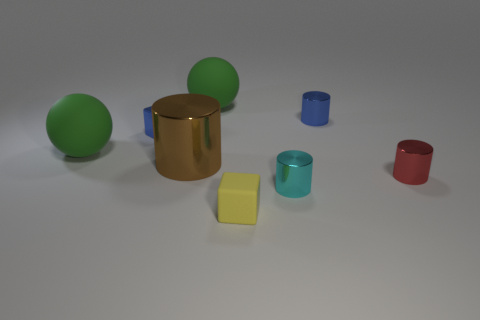There is a thing that is behind the small blue cylinder; what size is it?
Ensure brevity in your answer.  Large. What shape is the small thing that is the same color as the metal cube?
Give a very brief answer. Cylinder. Is the tiny red thing made of the same material as the blue thing left of the small rubber object?
Make the answer very short. Yes. What number of green rubber objects are in front of the large green rubber object that is behind the big green matte thing to the left of the brown cylinder?
Provide a short and direct response. 1. How many gray objects are large things or metallic blocks?
Offer a very short reply. 0. What is the shape of the large green matte thing that is in front of the blue shiny cylinder?
Provide a succinct answer. Sphere. There is a matte thing that is the same size as the red shiny cylinder; what color is it?
Offer a terse response. Yellow. Does the cyan metallic object have the same shape as the small metal thing to the left of the yellow rubber thing?
Ensure brevity in your answer.  No. There is a blue cube that is to the left of the object to the right of the tiny shiny cylinder that is behind the small red object; what is its material?
Offer a very short reply. Metal. What number of tiny objects are either green spheres or blue blocks?
Make the answer very short. 1. 